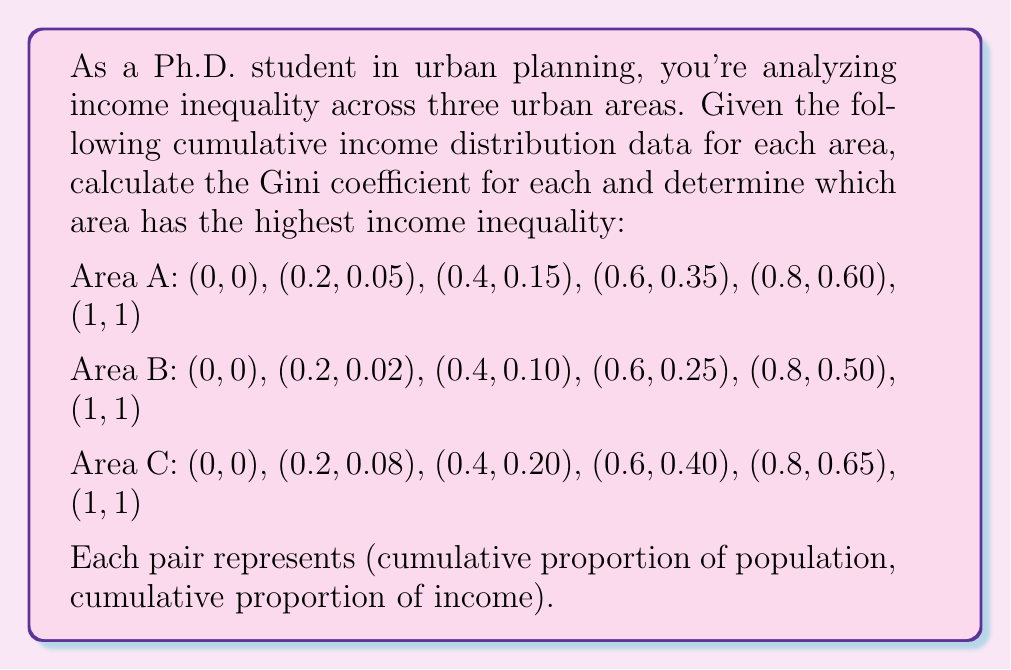Teach me how to tackle this problem. To solve this problem, we'll follow these steps for each area:

1. Calculate the area under the Lorenz curve
2. Calculate the area of perfect equality (triangle with base 1 and height 1)
3. Compute the Gini coefficient using the formula: $G = \frac{A - B}{A}$, where A is the area of perfect equality and B is the area under the Lorenz curve

For each area, we'll use the trapezoidal rule to approximate the area under the Lorenz curve:

$$ B = \sum_{i=1}^{n} \frac{1}{2}(y_i + y_{i-1})(x_i - x_{i-1}) $$

Where $(x_i, y_i)$ are the given points on the Lorenz curve.

Area A:
$B_A = \frac{1}{2}[(0+0.05)(0.2-0) + (0.05+0.15)(0.4-0.2) + (0.15+0.35)(0.6-0.4) + (0.35+0.60)(0.8-0.6) + (0.60+1)(1-0.8)]$
$B_A = 0.005 + 0.02 + 0.05 + 0.095 + 0.16 = 0.33$

$G_A = \frac{0.5 - 0.33}{0.5} = 0.34$

Area B:
$B_B = \frac{1}{2}[(0+0.02)(0.2-0) + (0.02+0.10)(0.4-0.2) + (0.10+0.25)(0.6-0.4) + (0.25+0.50)(0.8-0.6) + (0.50+1)(1-0.8)]$
$B_B = 0.002 + 0.012 + 0.035 + 0.075 + 0.15 = 0.274$

$G_B = \frac{0.5 - 0.274}{0.5} = 0.452$

Area C:
$B_C = \frac{1}{2}[(0+0.08)(0.2-0) + (0.08+0.20)(0.4-0.2) + (0.20+0.40)(0.6-0.4) + (0.40+0.65)(0.8-0.6) + (0.65+1)(1-0.8)]$
$B_C = 0.008 + 0.028 + 0.06 + 0.105 + 0.165 = 0.366$

$G_C = \frac{0.5 - 0.366}{0.5} = 0.268$

Comparing the Gini coefficients:
Area A: 0.34
Area B: 0.452
Area C: 0.268

The highest Gini coefficient indicates the highest income inequality.
Answer: Area B has the highest income inequality with a Gini coefficient of 0.452. 